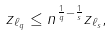Convert formula to latex. <formula><loc_0><loc_0><loc_500><loc_500>\| z \| _ { \ell _ { q } } \leq n ^ { \frac { 1 } { q } - \frac { 1 } { s } } \| z \| _ { \ell _ { s } } ,</formula> 